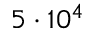<formula> <loc_0><loc_0><loc_500><loc_500>5 \cdot 1 0 ^ { 4 }</formula> 